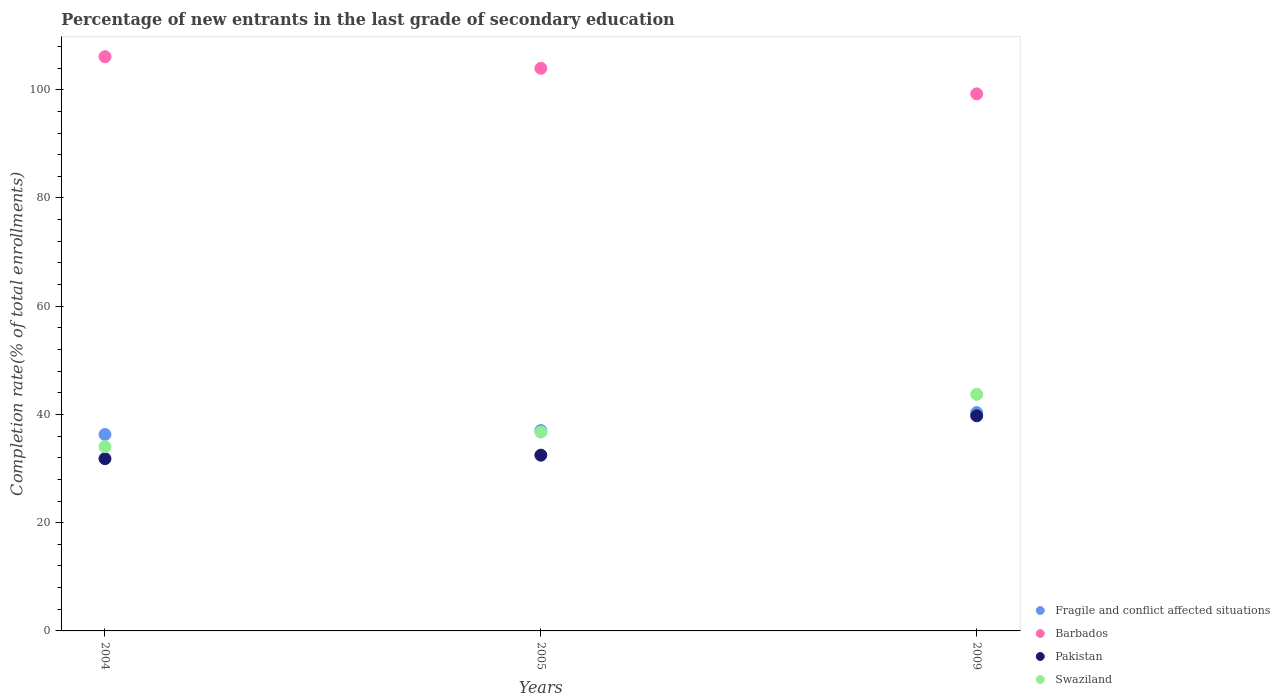Is the number of dotlines equal to the number of legend labels?
Give a very brief answer. Yes. What is the percentage of new entrants in Barbados in 2005?
Make the answer very short. 103.95. Across all years, what is the maximum percentage of new entrants in Fragile and conflict affected situations?
Your answer should be compact. 40.34. Across all years, what is the minimum percentage of new entrants in Fragile and conflict affected situations?
Offer a terse response. 36.3. In which year was the percentage of new entrants in Swaziland minimum?
Make the answer very short. 2004. What is the total percentage of new entrants in Barbados in the graph?
Provide a succinct answer. 309.3. What is the difference between the percentage of new entrants in Barbados in 2004 and that in 2005?
Keep it short and to the point. 2.15. What is the difference between the percentage of new entrants in Fragile and conflict affected situations in 2004 and the percentage of new entrants in Swaziland in 2005?
Your answer should be very brief. -0.44. What is the average percentage of new entrants in Pakistan per year?
Make the answer very short. 34.69. In the year 2009, what is the difference between the percentage of new entrants in Pakistan and percentage of new entrants in Barbados?
Ensure brevity in your answer.  -59.48. What is the ratio of the percentage of new entrants in Pakistan in 2004 to that in 2005?
Offer a terse response. 0.98. Is the percentage of new entrants in Pakistan in 2004 less than that in 2005?
Your response must be concise. Yes. Is the difference between the percentage of new entrants in Pakistan in 2004 and 2009 greater than the difference between the percentage of new entrants in Barbados in 2004 and 2009?
Ensure brevity in your answer.  No. What is the difference between the highest and the second highest percentage of new entrants in Barbados?
Your answer should be compact. 2.15. What is the difference between the highest and the lowest percentage of new entrants in Pakistan?
Make the answer very short. 7.93. How many dotlines are there?
Offer a very short reply. 4. What is the difference between two consecutive major ticks on the Y-axis?
Offer a terse response. 20. Does the graph contain any zero values?
Make the answer very short. No. Does the graph contain grids?
Keep it short and to the point. No. How many legend labels are there?
Keep it short and to the point. 4. What is the title of the graph?
Ensure brevity in your answer.  Percentage of new entrants in the last grade of secondary education. Does "Sudan" appear as one of the legend labels in the graph?
Offer a very short reply. No. What is the label or title of the Y-axis?
Offer a very short reply. Completion rate(% of total enrollments). What is the Completion rate(% of total enrollments) in Fragile and conflict affected situations in 2004?
Ensure brevity in your answer.  36.3. What is the Completion rate(% of total enrollments) in Barbados in 2004?
Ensure brevity in your answer.  106.11. What is the Completion rate(% of total enrollments) in Pakistan in 2004?
Offer a terse response. 31.83. What is the Completion rate(% of total enrollments) in Swaziland in 2004?
Ensure brevity in your answer.  34.04. What is the Completion rate(% of total enrollments) of Fragile and conflict affected situations in 2005?
Offer a very short reply. 37.02. What is the Completion rate(% of total enrollments) of Barbados in 2005?
Your response must be concise. 103.95. What is the Completion rate(% of total enrollments) in Pakistan in 2005?
Your answer should be very brief. 32.48. What is the Completion rate(% of total enrollments) of Swaziland in 2005?
Give a very brief answer. 36.74. What is the Completion rate(% of total enrollments) in Fragile and conflict affected situations in 2009?
Your response must be concise. 40.34. What is the Completion rate(% of total enrollments) of Barbados in 2009?
Provide a short and direct response. 99.24. What is the Completion rate(% of total enrollments) of Pakistan in 2009?
Provide a succinct answer. 39.76. What is the Completion rate(% of total enrollments) in Swaziland in 2009?
Provide a succinct answer. 43.72. Across all years, what is the maximum Completion rate(% of total enrollments) in Fragile and conflict affected situations?
Make the answer very short. 40.34. Across all years, what is the maximum Completion rate(% of total enrollments) of Barbados?
Your response must be concise. 106.11. Across all years, what is the maximum Completion rate(% of total enrollments) in Pakistan?
Ensure brevity in your answer.  39.76. Across all years, what is the maximum Completion rate(% of total enrollments) of Swaziland?
Make the answer very short. 43.72. Across all years, what is the minimum Completion rate(% of total enrollments) of Fragile and conflict affected situations?
Your answer should be compact. 36.3. Across all years, what is the minimum Completion rate(% of total enrollments) of Barbados?
Give a very brief answer. 99.24. Across all years, what is the minimum Completion rate(% of total enrollments) of Pakistan?
Ensure brevity in your answer.  31.83. Across all years, what is the minimum Completion rate(% of total enrollments) of Swaziland?
Make the answer very short. 34.04. What is the total Completion rate(% of total enrollments) of Fragile and conflict affected situations in the graph?
Offer a terse response. 113.66. What is the total Completion rate(% of total enrollments) of Barbados in the graph?
Make the answer very short. 309.3. What is the total Completion rate(% of total enrollments) in Pakistan in the graph?
Offer a very short reply. 104.06. What is the total Completion rate(% of total enrollments) in Swaziland in the graph?
Ensure brevity in your answer.  114.5. What is the difference between the Completion rate(% of total enrollments) of Fragile and conflict affected situations in 2004 and that in 2005?
Keep it short and to the point. -0.73. What is the difference between the Completion rate(% of total enrollments) of Barbados in 2004 and that in 2005?
Give a very brief answer. 2.15. What is the difference between the Completion rate(% of total enrollments) in Pakistan in 2004 and that in 2005?
Offer a terse response. -0.65. What is the difference between the Completion rate(% of total enrollments) in Swaziland in 2004 and that in 2005?
Offer a terse response. -2.7. What is the difference between the Completion rate(% of total enrollments) in Fragile and conflict affected situations in 2004 and that in 2009?
Keep it short and to the point. -4.05. What is the difference between the Completion rate(% of total enrollments) in Barbados in 2004 and that in 2009?
Offer a terse response. 6.87. What is the difference between the Completion rate(% of total enrollments) of Pakistan in 2004 and that in 2009?
Your response must be concise. -7.93. What is the difference between the Completion rate(% of total enrollments) of Swaziland in 2004 and that in 2009?
Your response must be concise. -9.67. What is the difference between the Completion rate(% of total enrollments) of Fragile and conflict affected situations in 2005 and that in 2009?
Provide a short and direct response. -3.32. What is the difference between the Completion rate(% of total enrollments) of Barbados in 2005 and that in 2009?
Make the answer very short. 4.72. What is the difference between the Completion rate(% of total enrollments) of Pakistan in 2005 and that in 2009?
Ensure brevity in your answer.  -7.28. What is the difference between the Completion rate(% of total enrollments) of Swaziland in 2005 and that in 2009?
Your response must be concise. -6.98. What is the difference between the Completion rate(% of total enrollments) of Fragile and conflict affected situations in 2004 and the Completion rate(% of total enrollments) of Barbados in 2005?
Provide a succinct answer. -67.66. What is the difference between the Completion rate(% of total enrollments) in Fragile and conflict affected situations in 2004 and the Completion rate(% of total enrollments) in Pakistan in 2005?
Give a very brief answer. 3.82. What is the difference between the Completion rate(% of total enrollments) in Fragile and conflict affected situations in 2004 and the Completion rate(% of total enrollments) in Swaziland in 2005?
Offer a very short reply. -0.44. What is the difference between the Completion rate(% of total enrollments) of Barbados in 2004 and the Completion rate(% of total enrollments) of Pakistan in 2005?
Offer a terse response. 73.63. What is the difference between the Completion rate(% of total enrollments) in Barbados in 2004 and the Completion rate(% of total enrollments) in Swaziland in 2005?
Give a very brief answer. 69.37. What is the difference between the Completion rate(% of total enrollments) in Pakistan in 2004 and the Completion rate(% of total enrollments) in Swaziland in 2005?
Ensure brevity in your answer.  -4.91. What is the difference between the Completion rate(% of total enrollments) in Fragile and conflict affected situations in 2004 and the Completion rate(% of total enrollments) in Barbados in 2009?
Your response must be concise. -62.94. What is the difference between the Completion rate(% of total enrollments) in Fragile and conflict affected situations in 2004 and the Completion rate(% of total enrollments) in Pakistan in 2009?
Keep it short and to the point. -3.46. What is the difference between the Completion rate(% of total enrollments) in Fragile and conflict affected situations in 2004 and the Completion rate(% of total enrollments) in Swaziland in 2009?
Your answer should be compact. -7.42. What is the difference between the Completion rate(% of total enrollments) of Barbados in 2004 and the Completion rate(% of total enrollments) of Pakistan in 2009?
Offer a very short reply. 66.35. What is the difference between the Completion rate(% of total enrollments) in Barbados in 2004 and the Completion rate(% of total enrollments) in Swaziland in 2009?
Provide a short and direct response. 62.39. What is the difference between the Completion rate(% of total enrollments) of Pakistan in 2004 and the Completion rate(% of total enrollments) of Swaziland in 2009?
Ensure brevity in your answer.  -11.89. What is the difference between the Completion rate(% of total enrollments) in Fragile and conflict affected situations in 2005 and the Completion rate(% of total enrollments) in Barbados in 2009?
Make the answer very short. -62.21. What is the difference between the Completion rate(% of total enrollments) of Fragile and conflict affected situations in 2005 and the Completion rate(% of total enrollments) of Pakistan in 2009?
Your response must be concise. -2.73. What is the difference between the Completion rate(% of total enrollments) in Fragile and conflict affected situations in 2005 and the Completion rate(% of total enrollments) in Swaziland in 2009?
Your response must be concise. -6.69. What is the difference between the Completion rate(% of total enrollments) in Barbados in 2005 and the Completion rate(% of total enrollments) in Pakistan in 2009?
Your answer should be compact. 64.2. What is the difference between the Completion rate(% of total enrollments) in Barbados in 2005 and the Completion rate(% of total enrollments) in Swaziland in 2009?
Your response must be concise. 60.24. What is the difference between the Completion rate(% of total enrollments) in Pakistan in 2005 and the Completion rate(% of total enrollments) in Swaziland in 2009?
Provide a short and direct response. -11.24. What is the average Completion rate(% of total enrollments) in Fragile and conflict affected situations per year?
Offer a very short reply. 37.89. What is the average Completion rate(% of total enrollments) of Barbados per year?
Offer a terse response. 103.1. What is the average Completion rate(% of total enrollments) of Pakistan per year?
Provide a succinct answer. 34.69. What is the average Completion rate(% of total enrollments) in Swaziland per year?
Offer a terse response. 38.17. In the year 2004, what is the difference between the Completion rate(% of total enrollments) in Fragile and conflict affected situations and Completion rate(% of total enrollments) in Barbados?
Provide a succinct answer. -69.81. In the year 2004, what is the difference between the Completion rate(% of total enrollments) in Fragile and conflict affected situations and Completion rate(% of total enrollments) in Pakistan?
Offer a very short reply. 4.47. In the year 2004, what is the difference between the Completion rate(% of total enrollments) in Fragile and conflict affected situations and Completion rate(% of total enrollments) in Swaziland?
Offer a terse response. 2.25. In the year 2004, what is the difference between the Completion rate(% of total enrollments) in Barbados and Completion rate(% of total enrollments) in Pakistan?
Keep it short and to the point. 74.28. In the year 2004, what is the difference between the Completion rate(% of total enrollments) of Barbados and Completion rate(% of total enrollments) of Swaziland?
Make the answer very short. 72.06. In the year 2004, what is the difference between the Completion rate(% of total enrollments) in Pakistan and Completion rate(% of total enrollments) in Swaziland?
Offer a very short reply. -2.22. In the year 2005, what is the difference between the Completion rate(% of total enrollments) in Fragile and conflict affected situations and Completion rate(% of total enrollments) in Barbados?
Offer a terse response. -66.93. In the year 2005, what is the difference between the Completion rate(% of total enrollments) of Fragile and conflict affected situations and Completion rate(% of total enrollments) of Pakistan?
Provide a short and direct response. 4.55. In the year 2005, what is the difference between the Completion rate(% of total enrollments) of Fragile and conflict affected situations and Completion rate(% of total enrollments) of Swaziland?
Ensure brevity in your answer.  0.28. In the year 2005, what is the difference between the Completion rate(% of total enrollments) of Barbados and Completion rate(% of total enrollments) of Pakistan?
Give a very brief answer. 71.48. In the year 2005, what is the difference between the Completion rate(% of total enrollments) in Barbados and Completion rate(% of total enrollments) in Swaziland?
Offer a very short reply. 67.21. In the year 2005, what is the difference between the Completion rate(% of total enrollments) of Pakistan and Completion rate(% of total enrollments) of Swaziland?
Offer a very short reply. -4.26. In the year 2009, what is the difference between the Completion rate(% of total enrollments) of Fragile and conflict affected situations and Completion rate(% of total enrollments) of Barbados?
Give a very brief answer. -58.89. In the year 2009, what is the difference between the Completion rate(% of total enrollments) in Fragile and conflict affected situations and Completion rate(% of total enrollments) in Pakistan?
Your response must be concise. 0.59. In the year 2009, what is the difference between the Completion rate(% of total enrollments) of Fragile and conflict affected situations and Completion rate(% of total enrollments) of Swaziland?
Your answer should be very brief. -3.37. In the year 2009, what is the difference between the Completion rate(% of total enrollments) in Barbados and Completion rate(% of total enrollments) in Pakistan?
Offer a terse response. 59.48. In the year 2009, what is the difference between the Completion rate(% of total enrollments) of Barbados and Completion rate(% of total enrollments) of Swaziland?
Ensure brevity in your answer.  55.52. In the year 2009, what is the difference between the Completion rate(% of total enrollments) of Pakistan and Completion rate(% of total enrollments) of Swaziland?
Keep it short and to the point. -3.96. What is the ratio of the Completion rate(% of total enrollments) of Fragile and conflict affected situations in 2004 to that in 2005?
Offer a very short reply. 0.98. What is the ratio of the Completion rate(% of total enrollments) in Barbados in 2004 to that in 2005?
Offer a terse response. 1.02. What is the ratio of the Completion rate(% of total enrollments) in Swaziland in 2004 to that in 2005?
Keep it short and to the point. 0.93. What is the ratio of the Completion rate(% of total enrollments) of Fragile and conflict affected situations in 2004 to that in 2009?
Ensure brevity in your answer.  0.9. What is the ratio of the Completion rate(% of total enrollments) in Barbados in 2004 to that in 2009?
Offer a very short reply. 1.07. What is the ratio of the Completion rate(% of total enrollments) of Pakistan in 2004 to that in 2009?
Your response must be concise. 0.8. What is the ratio of the Completion rate(% of total enrollments) of Swaziland in 2004 to that in 2009?
Offer a terse response. 0.78. What is the ratio of the Completion rate(% of total enrollments) in Fragile and conflict affected situations in 2005 to that in 2009?
Offer a very short reply. 0.92. What is the ratio of the Completion rate(% of total enrollments) of Barbados in 2005 to that in 2009?
Offer a very short reply. 1.05. What is the ratio of the Completion rate(% of total enrollments) of Pakistan in 2005 to that in 2009?
Your response must be concise. 0.82. What is the ratio of the Completion rate(% of total enrollments) in Swaziland in 2005 to that in 2009?
Give a very brief answer. 0.84. What is the difference between the highest and the second highest Completion rate(% of total enrollments) of Fragile and conflict affected situations?
Your answer should be compact. 3.32. What is the difference between the highest and the second highest Completion rate(% of total enrollments) in Barbados?
Your answer should be compact. 2.15. What is the difference between the highest and the second highest Completion rate(% of total enrollments) in Pakistan?
Your answer should be compact. 7.28. What is the difference between the highest and the second highest Completion rate(% of total enrollments) of Swaziland?
Provide a succinct answer. 6.98. What is the difference between the highest and the lowest Completion rate(% of total enrollments) in Fragile and conflict affected situations?
Your answer should be very brief. 4.05. What is the difference between the highest and the lowest Completion rate(% of total enrollments) in Barbados?
Your response must be concise. 6.87. What is the difference between the highest and the lowest Completion rate(% of total enrollments) of Pakistan?
Make the answer very short. 7.93. What is the difference between the highest and the lowest Completion rate(% of total enrollments) of Swaziland?
Provide a short and direct response. 9.67. 